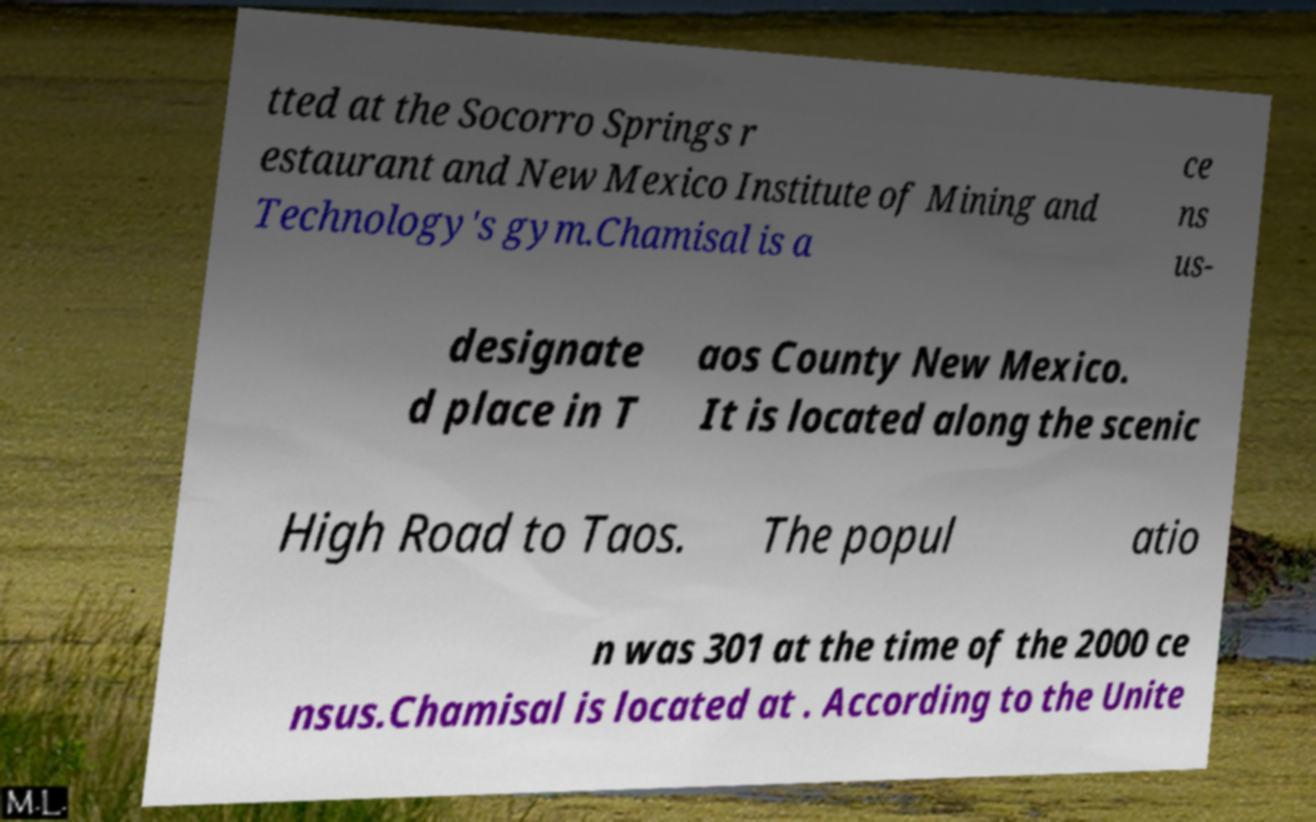Can you read and provide the text displayed in the image?This photo seems to have some interesting text. Can you extract and type it out for me? tted at the Socorro Springs r estaurant and New Mexico Institute of Mining and Technology's gym.Chamisal is a ce ns us- designate d place in T aos County New Mexico. It is located along the scenic High Road to Taos. The popul atio n was 301 at the time of the 2000 ce nsus.Chamisal is located at . According to the Unite 